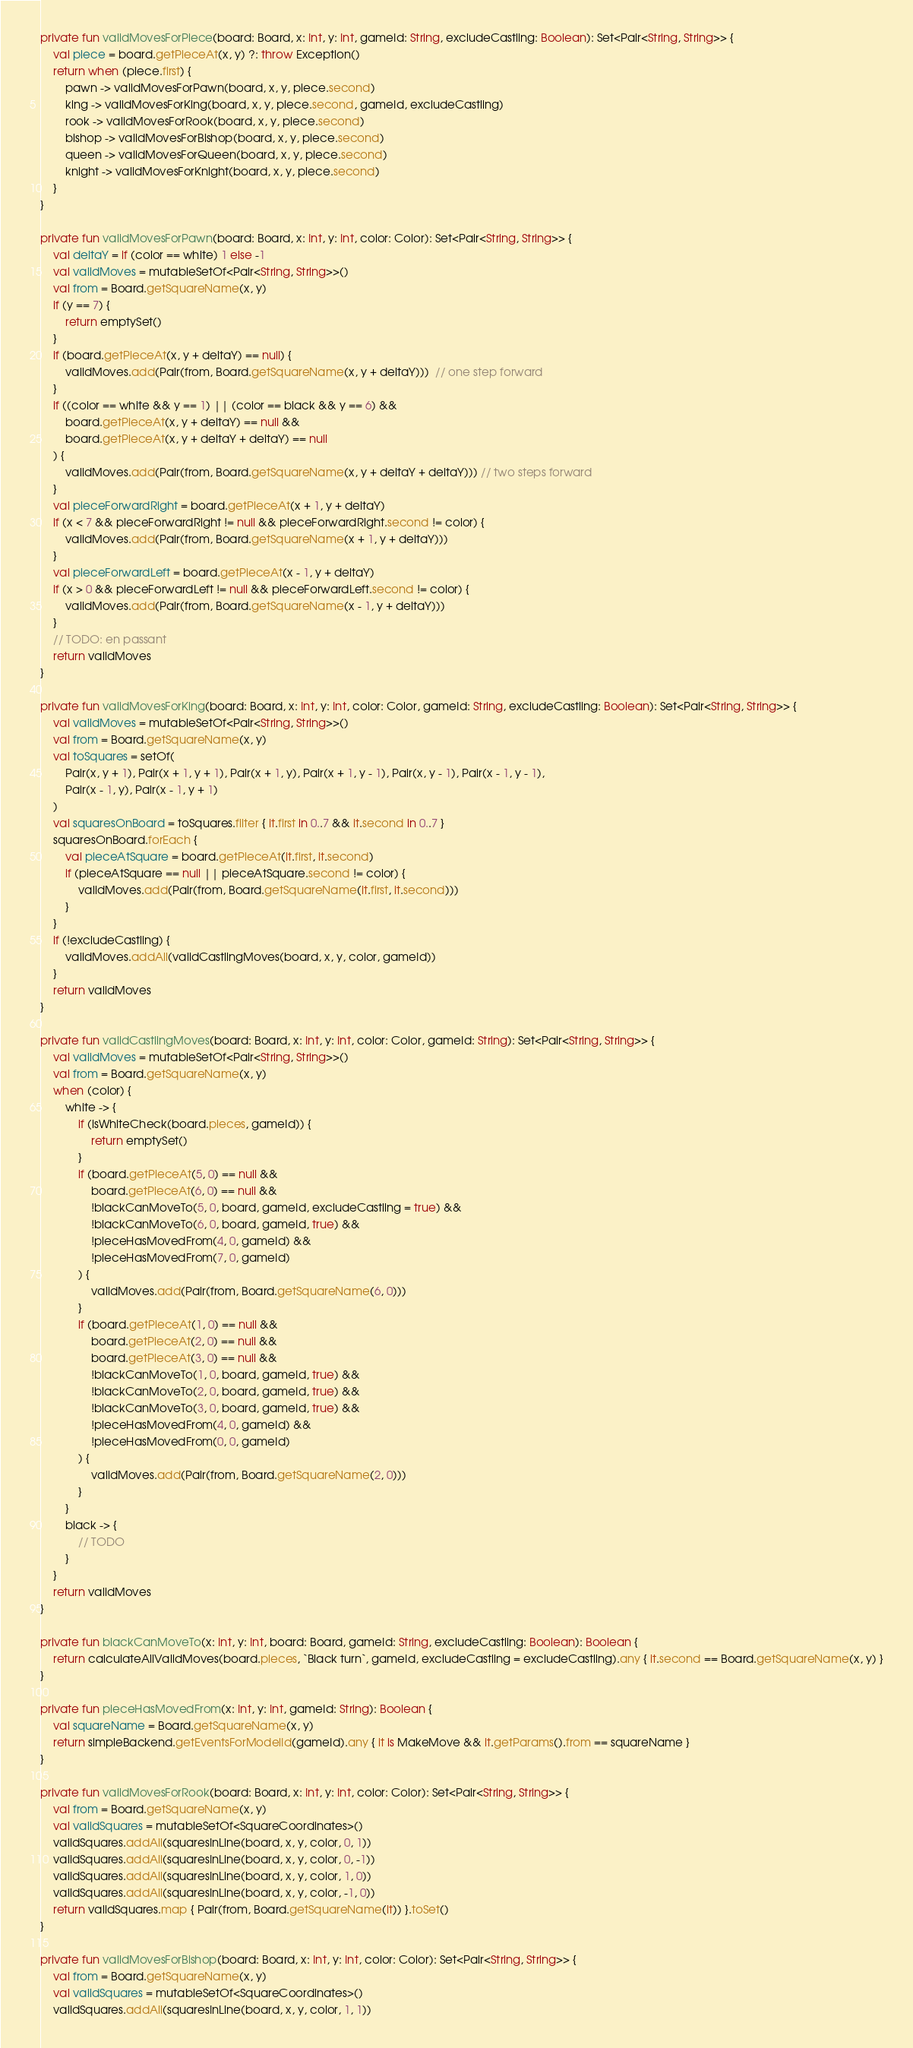Convert code to text. <code><loc_0><loc_0><loc_500><loc_500><_Kotlin_>private fun validMovesForPiece(board: Board, x: Int, y: Int, gameId: String, excludeCastling: Boolean): Set<Pair<String, String>> {
    val piece = board.getPieceAt(x, y) ?: throw Exception()
    return when (piece.first) {
        pawn -> validMovesForPawn(board, x, y, piece.second)
        king -> validMovesForKing(board, x, y, piece.second, gameId, excludeCastling)
        rook -> validMovesForRook(board, x, y, piece.second)
        bishop -> validMovesForBishop(board, x, y, piece.second)
        queen -> validMovesForQueen(board, x, y, piece.second)
        knight -> validMovesForKnight(board, x, y, piece.second)
    }
}

private fun validMovesForPawn(board: Board, x: Int, y: Int, color: Color): Set<Pair<String, String>> {
    val deltaY = if (color == white) 1 else -1
    val validMoves = mutableSetOf<Pair<String, String>>()
    val from = Board.getSquareName(x, y)
    if (y == 7) {
        return emptySet()
    }
    if (board.getPieceAt(x, y + deltaY) == null) {
        validMoves.add(Pair(from, Board.getSquareName(x, y + deltaY)))  // one step forward
    }
    if ((color == white && y == 1) || (color == black && y == 6) &&
        board.getPieceAt(x, y + deltaY) == null &&
        board.getPieceAt(x, y + deltaY + deltaY) == null
    ) {
        validMoves.add(Pair(from, Board.getSquareName(x, y + deltaY + deltaY))) // two steps forward
    }
    val pieceForwardRight = board.getPieceAt(x + 1, y + deltaY)
    if (x < 7 && pieceForwardRight != null && pieceForwardRight.second != color) {
        validMoves.add(Pair(from, Board.getSquareName(x + 1, y + deltaY)))
    }
    val pieceForwardLeft = board.getPieceAt(x - 1, y + deltaY)
    if (x > 0 && pieceForwardLeft != null && pieceForwardLeft.second != color) {
        validMoves.add(Pair(from, Board.getSquareName(x - 1, y + deltaY)))
    }
    // TODO: en passant
    return validMoves
}

private fun validMovesForKing(board: Board, x: Int, y: Int, color: Color, gameId: String, excludeCastling: Boolean): Set<Pair<String, String>> {
    val validMoves = mutableSetOf<Pair<String, String>>()
    val from = Board.getSquareName(x, y)
    val toSquares = setOf(
        Pair(x, y + 1), Pair(x + 1, y + 1), Pair(x + 1, y), Pair(x + 1, y - 1), Pair(x, y - 1), Pair(x - 1, y - 1),
        Pair(x - 1, y), Pair(x - 1, y + 1)
    )
    val squaresOnBoard = toSquares.filter { it.first in 0..7 && it.second in 0..7 }
    squaresOnBoard.forEach {
        val pieceAtSquare = board.getPieceAt(it.first, it.second)
        if (pieceAtSquare == null || pieceAtSquare.second != color) {
            validMoves.add(Pair(from, Board.getSquareName(it.first, it.second)))
        }
    }
    if (!excludeCastling) {
        validMoves.addAll(validCastlingMoves(board, x, y, color, gameId))
    }
    return validMoves
}

private fun validCastlingMoves(board: Board, x: Int, y: Int, color: Color, gameId: String): Set<Pair<String, String>> {
    val validMoves = mutableSetOf<Pair<String, String>>()
    val from = Board.getSquareName(x, y)
    when (color) {
        white -> {
            if (isWhiteCheck(board.pieces, gameId)) {
                return emptySet()
            }
            if (board.getPieceAt(5, 0) == null &&
                board.getPieceAt(6, 0) == null &&
                !blackCanMoveTo(5, 0, board, gameId, excludeCastling = true) &&
                !blackCanMoveTo(6, 0, board, gameId, true) &&
                !pieceHasMovedFrom(4, 0, gameId) &&
                !pieceHasMovedFrom(7, 0, gameId)
            ) {
                validMoves.add(Pair(from, Board.getSquareName(6, 0)))
            }
            if (board.getPieceAt(1, 0) == null &&
                board.getPieceAt(2, 0) == null &&
                board.getPieceAt(3, 0) == null &&
                !blackCanMoveTo(1, 0, board, gameId, true) &&
                !blackCanMoveTo(2, 0, board, gameId, true) &&
                !blackCanMoveTo(3, 0, board, gameId, true) &&
                !pieceHasMovedFrom(4, 0, gameId) &&
                !pieceHasMovedFrom(0, 0, gameId)
            ) {
                validMoves.add(Pair(from, Board.getSquareName(2, 0)))
            }
        }
        black -> {
            // TODO
        }
    }
    return validMoves
}

private fun blackCanMoveTo(x: Int, y: Int, board: Board, gameId: String, excludeCastling: Boolean): Boolean {
    return calculateAllValidMoves(board.pieces, `Black turn`, gameId, excludeCastling = excludeCastling).any { it.second == Board.getSquareName(x, y) }
}

private fun pieceHasMovedFrom(x: Int, y: Int, gameId: String): Boolean {
    val squareName = Board.getSquareName(x, y)
    return simpleBackend.getEventsForModelId(gameId).any { it is MakeMove && it.getParams().from == squareName }
}

private fun validMovesForRook(board: Board, x: Int, y: Int, color: Color): Set<Pair<String, String>> {
    val from = Board.getSquareName(x, y)
    val validSquares = mutableSetOf<SquareCoordinates>()
    validSquares.addAll(squaresInLine(board, x, y, color, 0, 1))
    validSquares.addAll(squaresInLine(board, x, y, color, 0, -1))
    validSquares.addAll(squaresInLine(board, x, y, color, 1, 0))
    validSquares.addAll(squaresInLine(board, x, y, color, -1, 0))
    return validSquares.map { Pair(from, Board.getSquareName(it)) }.toSet()
}

private fun validMovesForBishop(board: Board, x: Int, y: Int, color: Color): Set<Pair<String, String>> {
    val from = Board.getSquareName(x, y)
    val validSquares = mutableSetOf<SquareCoordinates>()
    validSquares.addAll(squaresInLine(board, x, y, color, 1, 1))</code> 